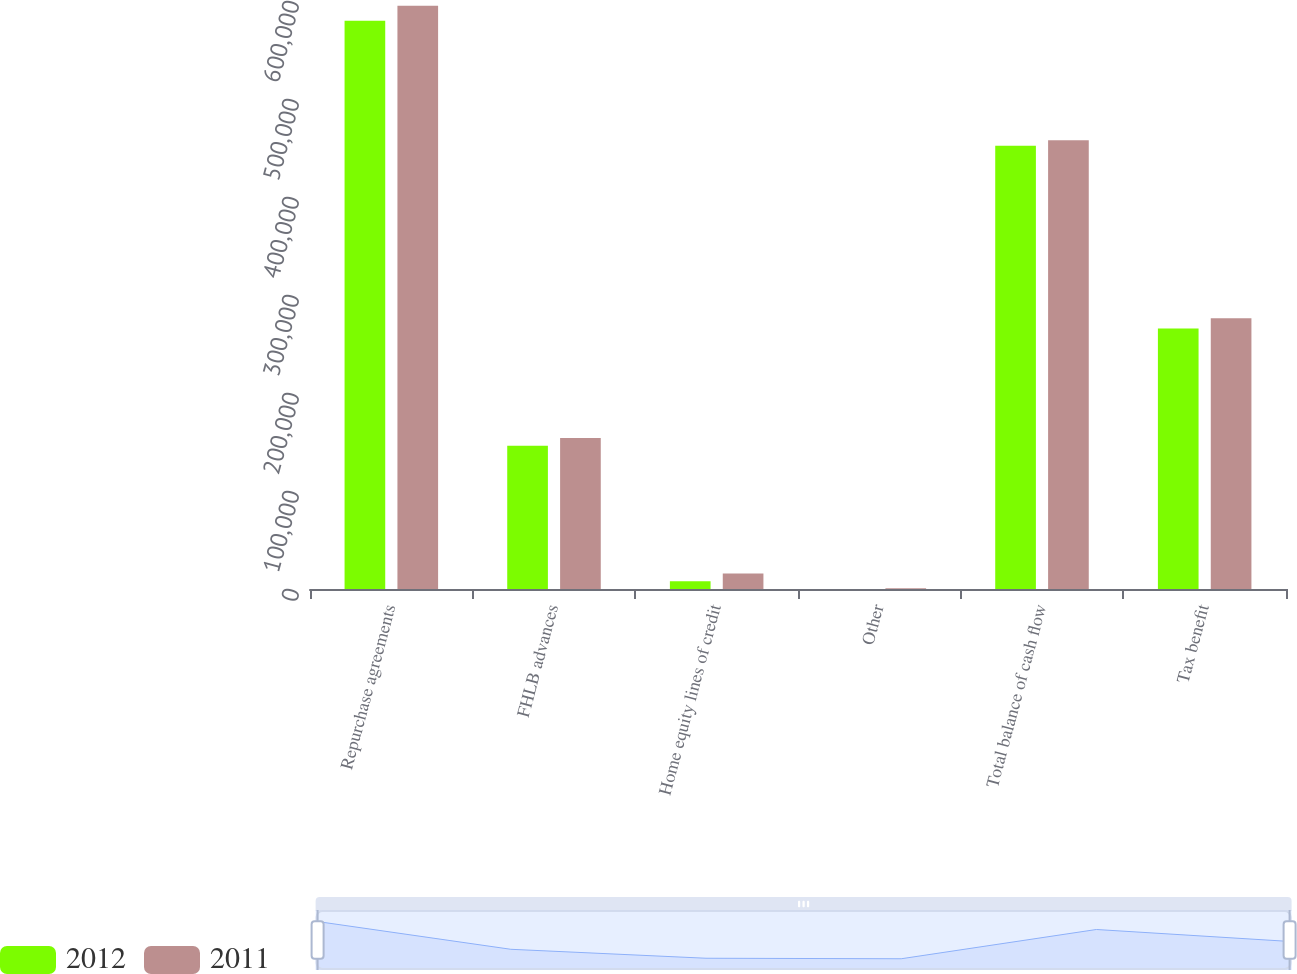Convert chart to OTSL. <chart><loc_0><loc_0><loc_500><loc_500><stacked_bar_chart><ecel><fcel>Repurchase agreements<fcel>FHLB advances<fcel>Home equity lines of credit<fcel>Other<fcel>Total balance of cash flow<fcel>Tax benefit<nl><fcel>2012<fcel>579763<fcel>146253<fcel>7854<fcel>116<fcel>452341<fcel>265705<nl><fcel>2011<fcel>595202<fcel>154082<fcel>15772<fcel>655<fcel>457953<fcel>276214<nl></chart> 